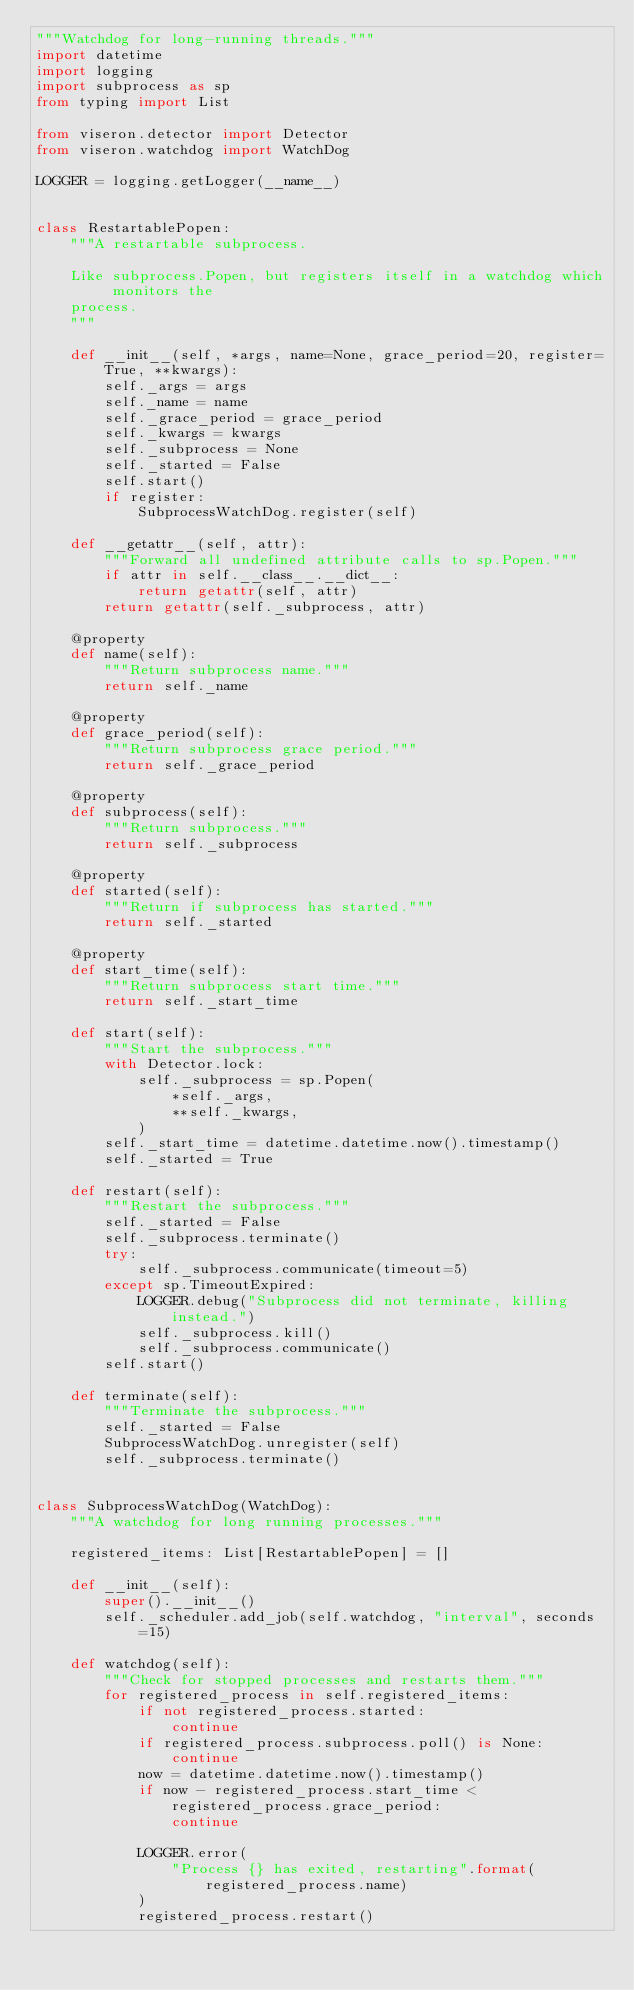Convert code to text. <code><loc_0><loc_0><loc_500><loc_500><_Python_>"""Watchdog for long-running threads."""
import datetime
import logging
import subprocess as sp
from typing import List

from viseron.detector import Detector
from viseron.watchdog import WatchDog

LOGGER = logging.getLogger(__name__)


class RestartablePopen:
    """A restartable subprocess.

    Like subprocess.Popen, but registers itself in a watchdog which monitors the
    process.
    """

    def __init__(self, *args, name=None, grace_period=20, register=True, **kwargs):
        self._args = args
        self._name = name
        self._grace_period = grace_period
        self._kwargs = kwargs
        self._subprocess = None
        self._started = False
        self.start()
        if register:
            SubprocessWatchDog.register(self)

    def __getattr__(self, attr):
        """Forward all undefined attribute calls to sp.Popen."""
        if attr in self.__class__.__dict__:
            return getattr(self, attr)
        return getattr(self._subprocess, attr)

    @property
    def name(self):
        """Return subprocess name."""
        return self._name

    @property
    def grace_period(self):
        """Return subprocess grace period."""
        return self._grace_period

    @property
    def subprocess(self):
        """Return subprocess."""
        return self._subprocess

    @property
    def started(self):
        """Return if subprocess has started."""
        return self._started

    @property
    def start_time(self):
        """Return subprocess start time."""
        return self._start_time

    def start(self):
        """Start the subprocess."""
        with Detector.lock:
            self._subprocess = sp.Popen(
                *self._args,
                **self._kwargs,
            )
        self._start_time = datetime.datetime.now().timestamp()
        self._started = True

    def restart(self):
        """Restart the subprocess."""
        self._started = False
        self._subprocess.terminate()
        try:
            self._subprocess.communicate(timeout=5)
        except sp.TimeoutExpired:
            LOGGER.debug("Subprocess did not terminate, killing instead.")
            self._subprocess.kill()
            self._subprocess.communicate()
        self.start()

    def terminate(self):
        """Terminate the subprocess."""
        self._started = False
        SubprocessWatchDog.unregister(self)
        self._subprocess.terminate()


class SubprocessWatchDog(WatchDog):
    """A watchdog for long running processes."""

    registered_items: List[RestartablePopen] = []

    def __init__(self):
        super().__init__()
        self._scheduler.add_job(self.watchdog, "interval", seconds=15)

    def watchdog(self):
        """Check for stopped processes and restarts them."""
        for registered_process in self.registered_items:
            if not registered_process.started:
                continue
            if registered_process.subprocess.poll() is None:
                continue
            now = datetime.datetime.now().timestamp()
            if now - registered_process.start_time < registered_process.grace_period:
                continue

            LOGGER.error(
                "Process {} has exited, restarting".format(registered_process.name)
            )
            registered_process.restart()
</code> 